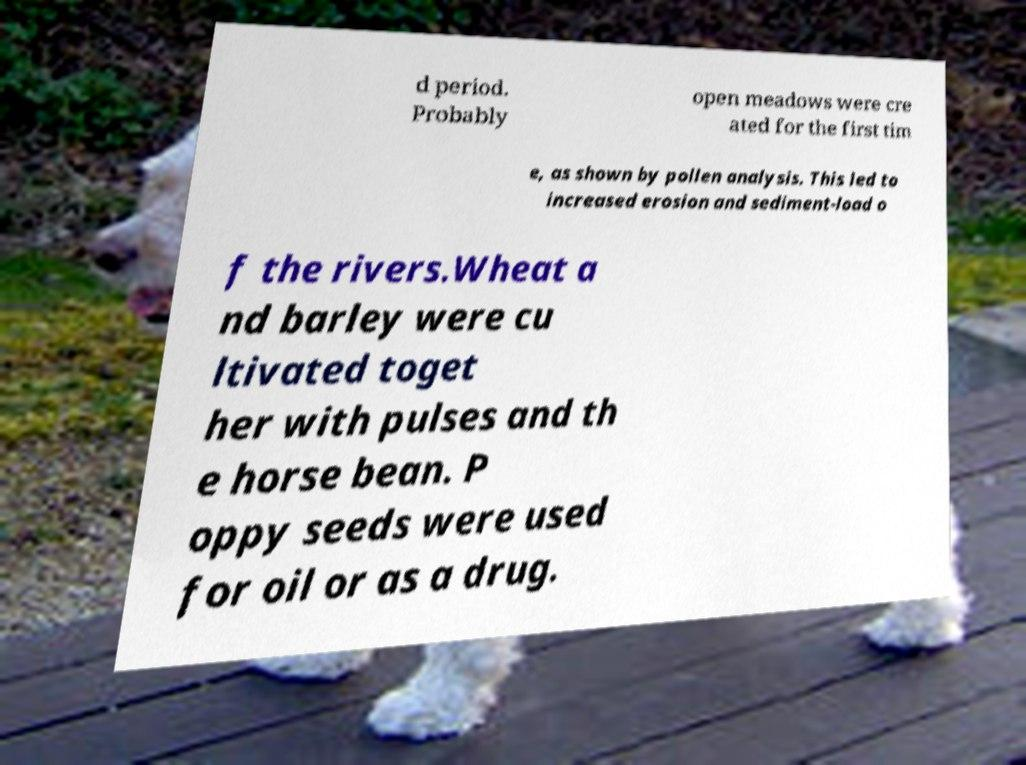I need the written content from this picture converted into text. Can you do that? d period. Probably open meadows were cre ated for the first tim e, as shown by pollen analysis. This led to increased erosion and sediment-load o f the rivers.Wheat a nd barley were cu ltivated toget her with pulses and th e horse bean. P oppy seeds were used for oil or as a drug. 